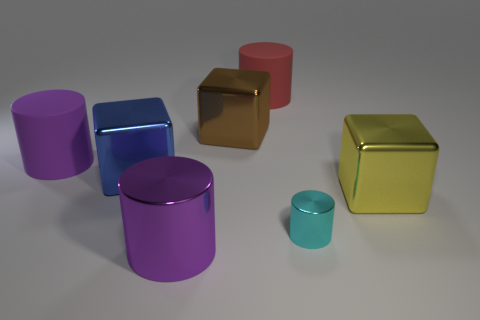What is the large purple object in front of the purple object behind the big shiny block that is to the right of the red object made of?
Your answer should be compact. Metal. Is the number of purple cylinders greater than the number of red rubber cylinders?
Give a very brief answer. Yes. Is there any other thing of the same color as the big metal cylinder?
Ensure brevity in your answer.  Yes. There is a blue block that is made of the same material as the yellow cube; what is its size?
Make the answer very short. Large. What is the material of the large red thing?
Your answer should be very brief. Rubber. How many gray matte blocks have the same size as the purple rubber cylinder?
Make the answer very short. 0. There is a matte thing that is the same color as the large metallic cylinder; what shape is it?
Make the answer very short. Cylinder. Are there any blue objects that have the same shape as the yellow metal object?
Provide a succinct answer. Yes. There is a metallic cylinder that is the same size as the yellow object; what color is it?
Offer a terse response. Purple. The cylinder that is left of the purple thing that is in front of the yellow metal block is what color?
Provide a succinct answer. Purple. 